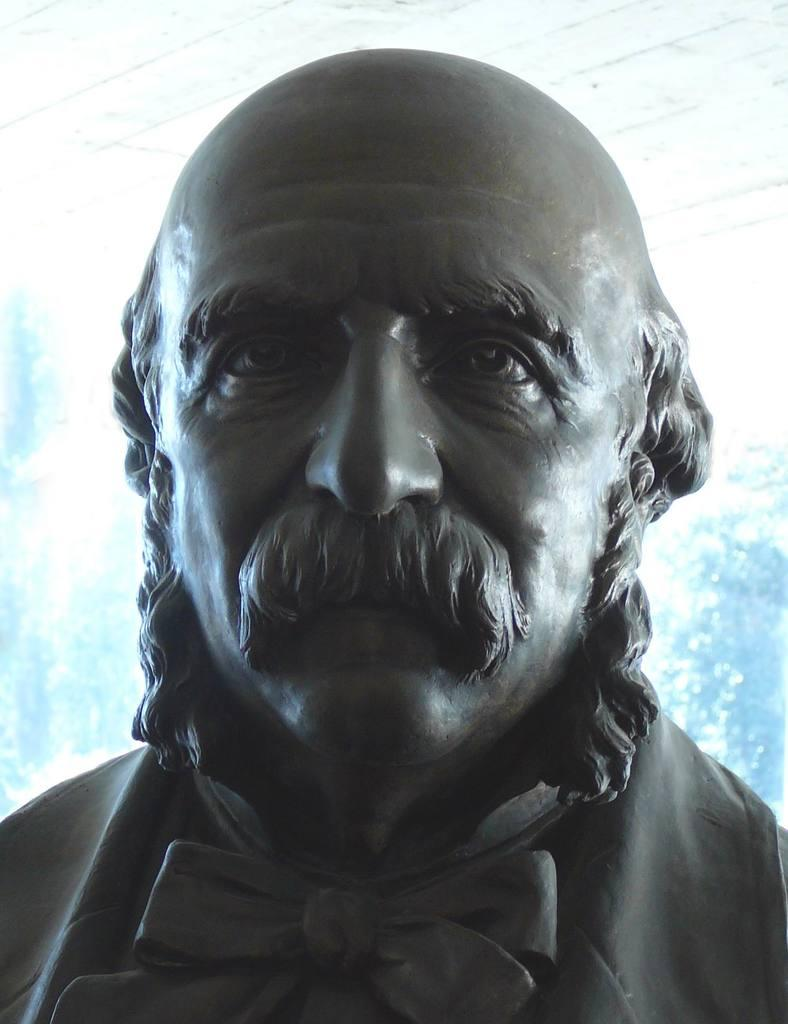What is the main subject of the image? There is a sculpture of a man in the image. What type of regret can be seen on the face of the goose in the image? There is no goose present in the image, and therefore no regret can be seen on its face. 